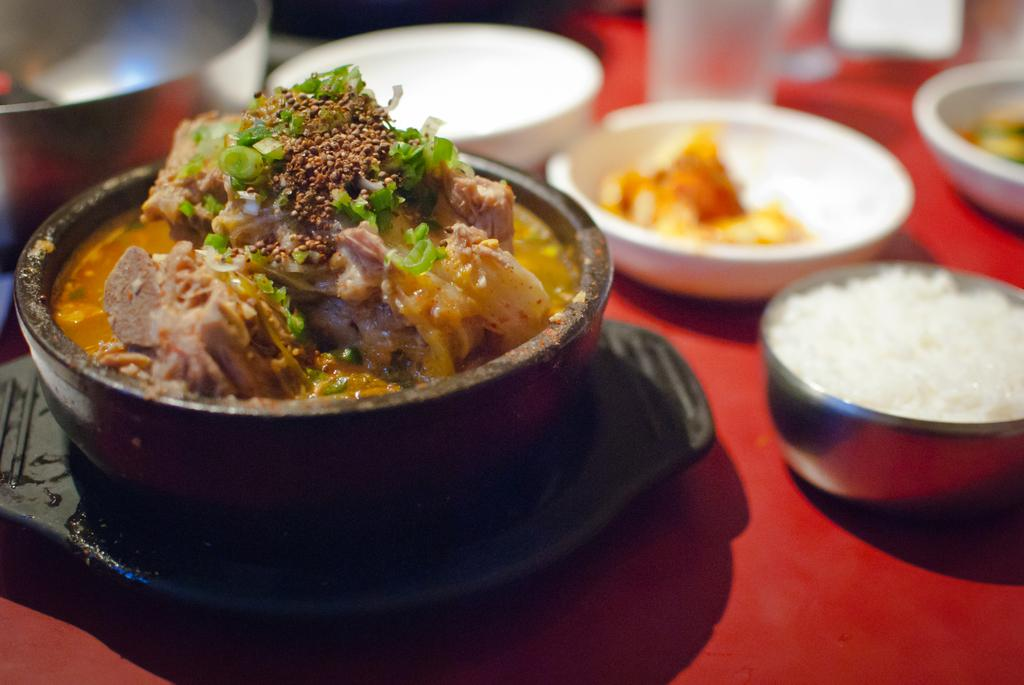What type of dishware can be seen in the image? There are bowls, a glass, and a plate in the image. What is present on the dishware? There are food items in the image. What is covering the table in the image? There is a cloth on the table in the image. How many yaks are visible in the image? There are no yaks present in the image. What type of knot is used to secure the cloth on the table? There is no mention of a knot in the image, and the cloth's method of attachment is not visible. 